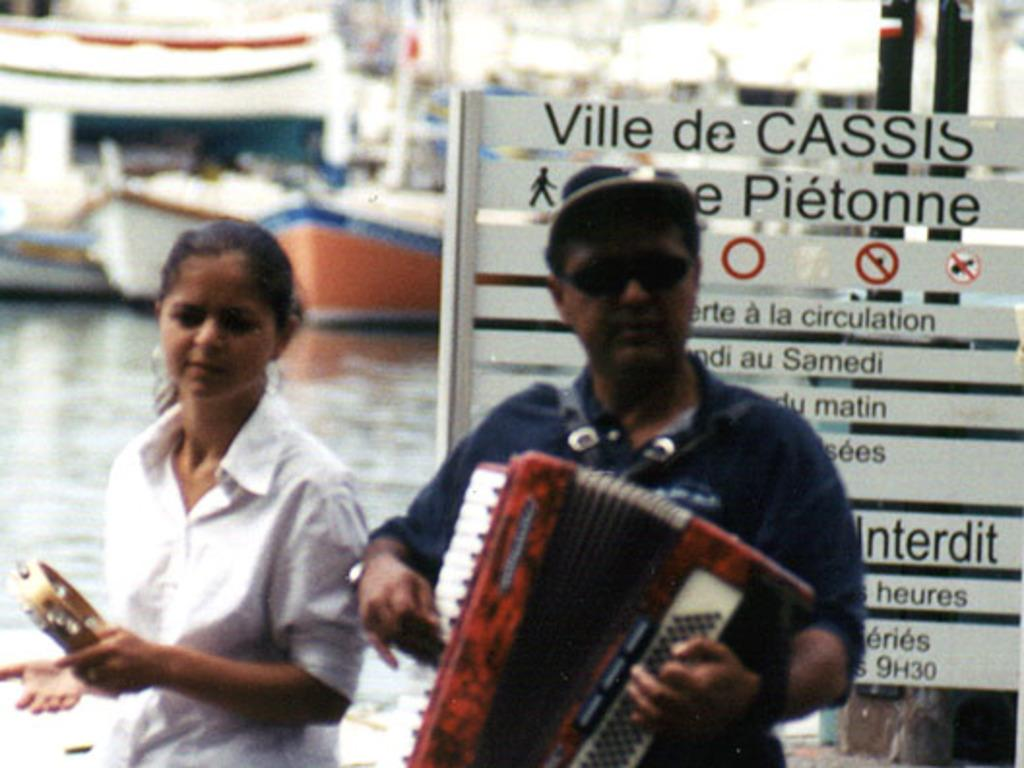How many people are present in the image? There are two people, a man and a woman, present in the image. What are the man and woman doing in the image? Both the man and woman are holding musical instruments. What can be seen in the background of the image? There is a board with text on it, poles, and boats in a water body visible in the background. What type of head can be seen on the woman's shirt in the image? There is no head or shirt visible on the woman in the image; she is wearing a dress and holding a musical instrument. 